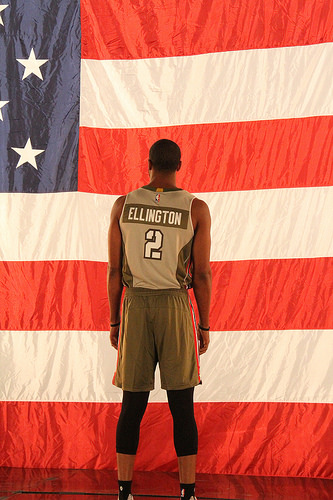<image>
Can you confirm if the man is behind the flag? No. The man is not behind the flag. From this viewpoint, the man appears to be positioned elsewhere in the scene. 